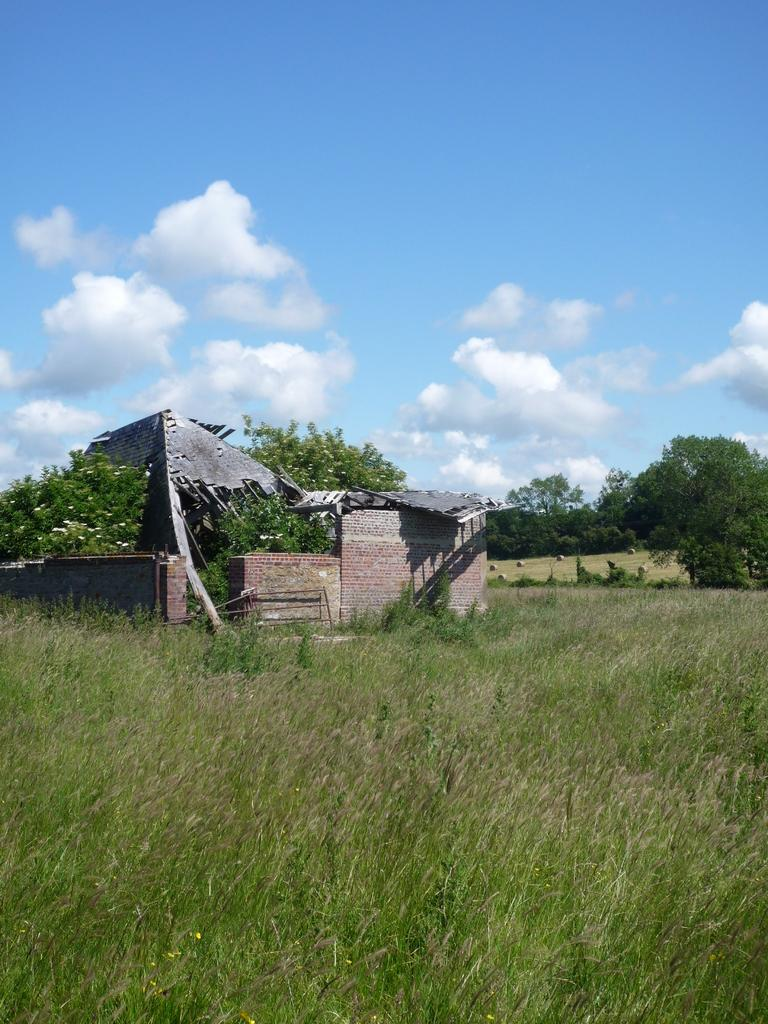What is the main subject in the center of the image? There is a house in the center of the image. What can be seen at the bottom of the image? There are plants at the bottom of the image. What is visible in the background of the image? There are trees and a wall in the background of the image. How does the house express humor in the image? The house does not express humor in the image; it is a static structure. 